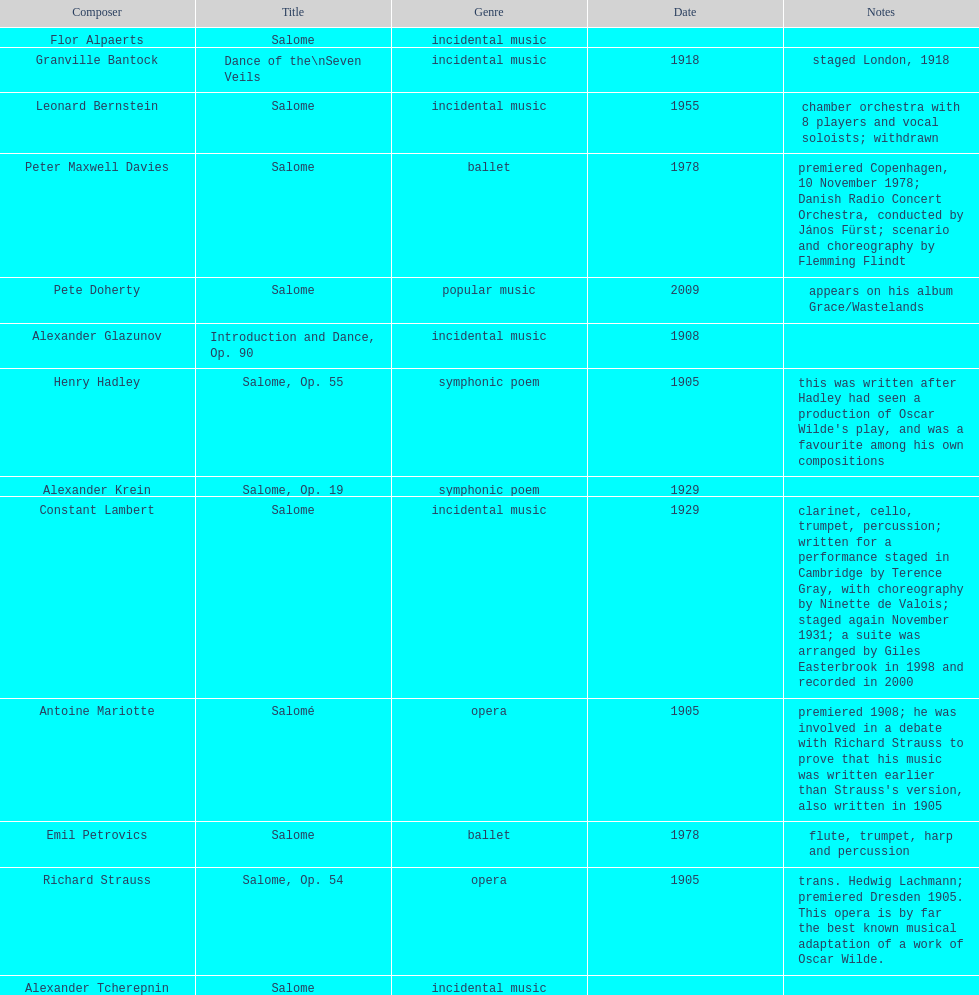What is the total number of creations in the incidental music category? 6. 